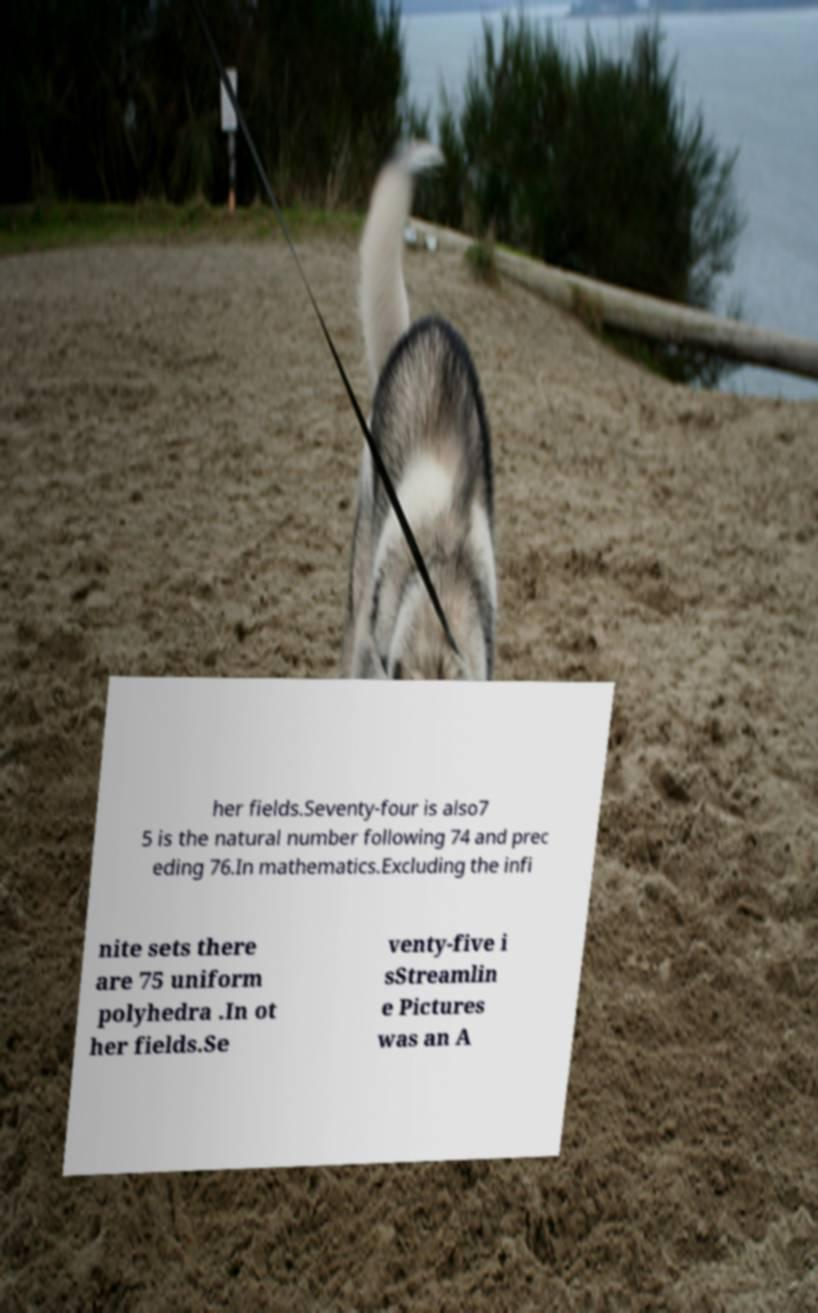Please read and relay the text visible in this image. What does it say? her fields.Seventy-four is also7 5 is the natural number following 74 and prec eding 76.In mathematics.Excluding the infi nite sets there are 75 uniform polyhedra .In ot her fields.Se venty-five i sStreamlin e Pictures was an A 